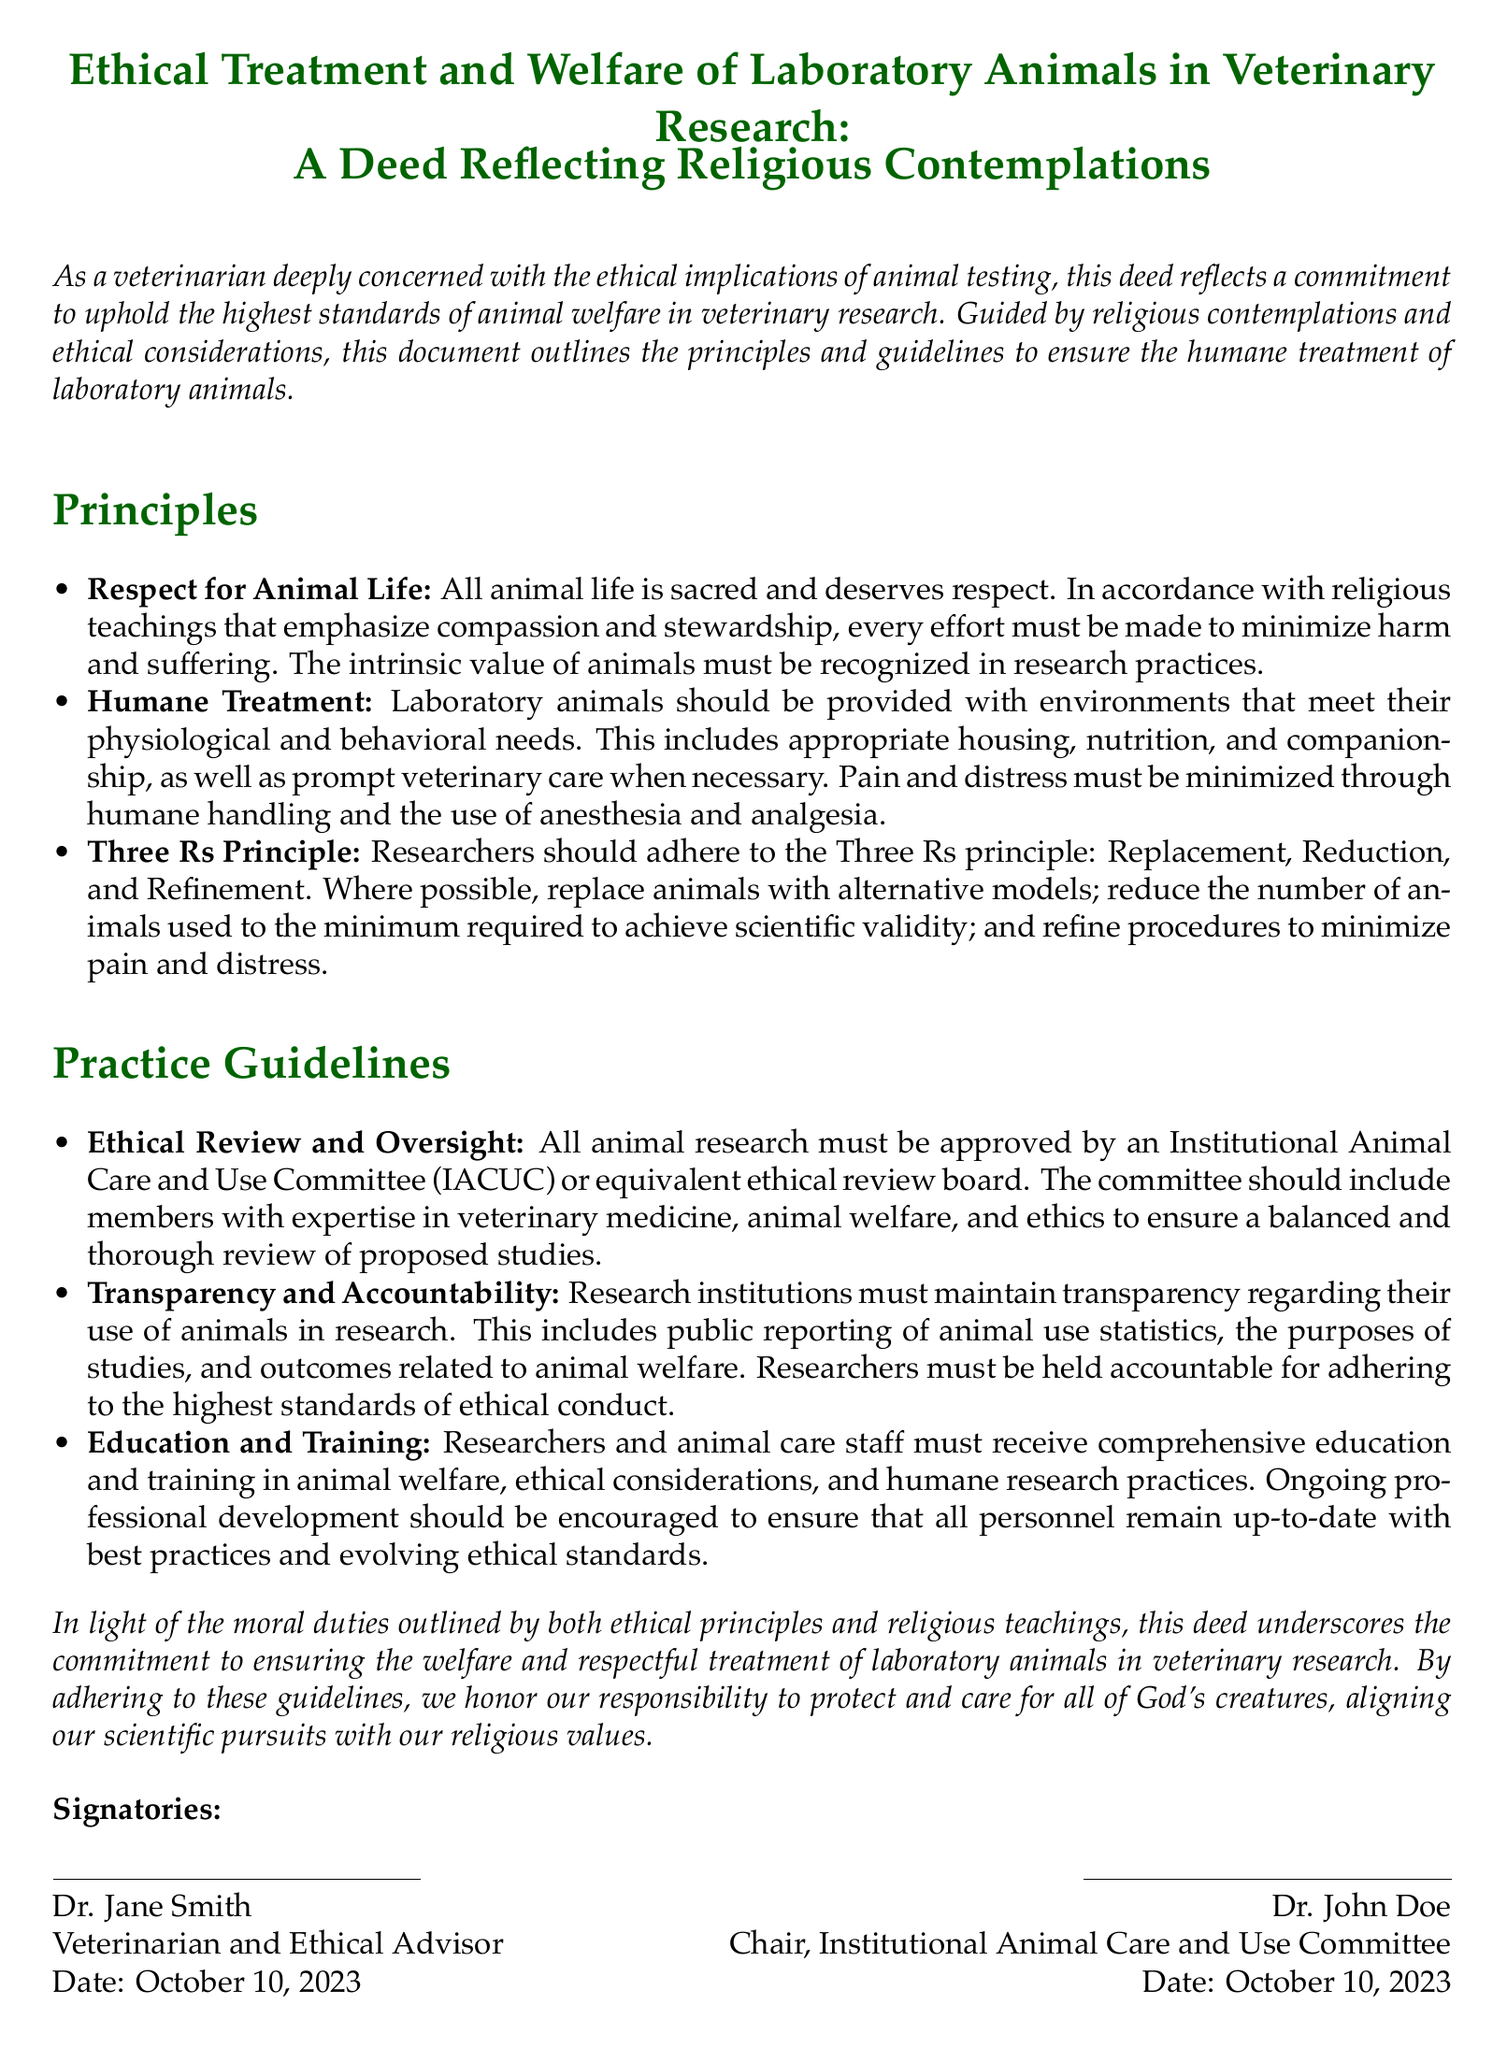What is the title of the document? The title is a central heading that summarizes the document's purpose and subject matter.
Answer: Ethical Treatment and Welfare of Laboratory Animals in Veterinary Research: A Deed Reflecting Religious Contemplations Who is the first signatory of the deed? The first signatory appears at the end of the document, indicating who has endorsed the principles.
Answer: Dr. Jane Smith What does the Three Rs principle stand for? The Three Rs principle is a widely accepted framework in research ethics that includes specific concepts, indicated in the document.
Answer: Replacement, Reduction, and Refinement When was the deed signed? The date provided corresponds to when the document was officially endorsed by the signatories.
Answer: October 10, 2023 What is the main focus of the Principles section? The main focus covers key commitments related to the ethical treatment of animals in research.
Answer: Respect for Animal Life What is the purpose of the Institutional Animal Care and Use Committee mentioned? This committee is essential for overseeing ethical practices in research involving animals, ensuring compliance and animal welfare.
Answer: Ethical Review and Oversight How many signatories are there on the deed? The number of signatories can be determined by counting the individuals listed at the end of the document.
Answer: 2 What is emphasized in the Practice Guidelines section? This section contains specific practices and standards to ensure ethical treatment of laboratory animals in research.
Answer: Education and Training 